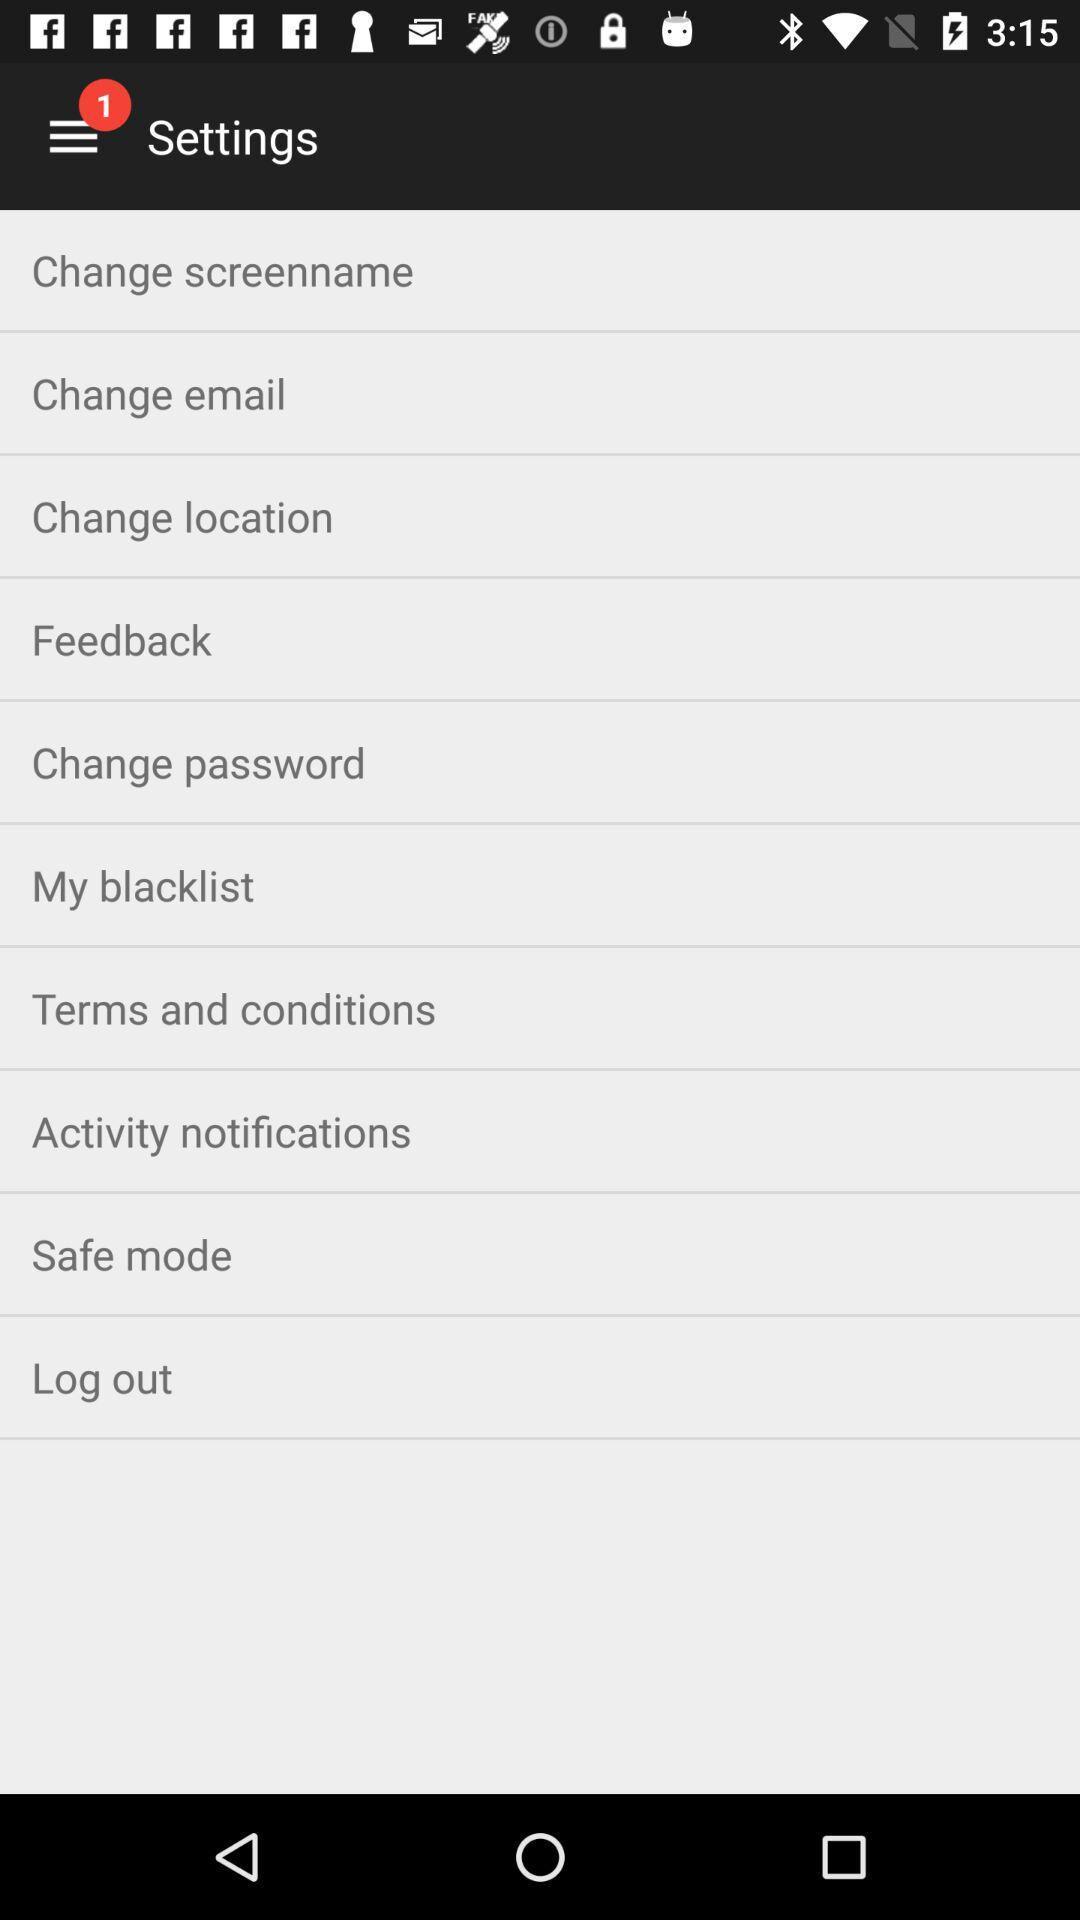Where is the user located?
When the provided information is insufficient, respond with <no answer>. <no answer> 